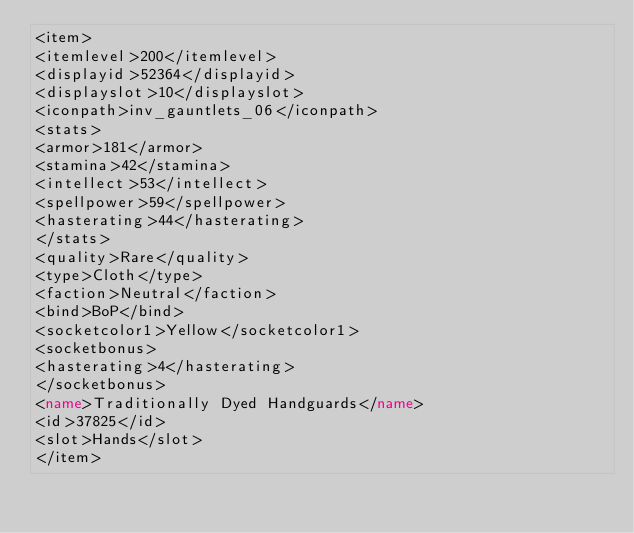Convert code to text. <code><loc_0><loc_0><loc_500><loc_500><_XML_><item>
<itemlevel>200</itemlevel>
<displayid>52364</displayid>
<displayslot>10</displayslot>
<iconpath>inv_gauntlets_06</iconpath>
<stats>
<armor>181</armor>
<stamina>42</stamina>
<intellect>53</intellect>
<spellpower>59</spellpower>
<hasterating>44</hasterating>
</stats>
<quality>Rare</quality>
<type>Cloth</type>
<faction>Neutral</faction>
<bind>BoP</bind>
<socketcolor1>Yellow</socketcolor1>
<socketbonus>
<hasterating>4</hasterating>
</socketbonus>
<name>Traditionally Dyed Handguards</name>
<id>37825</id>
<slot>Hands</slot>
</item></code> 